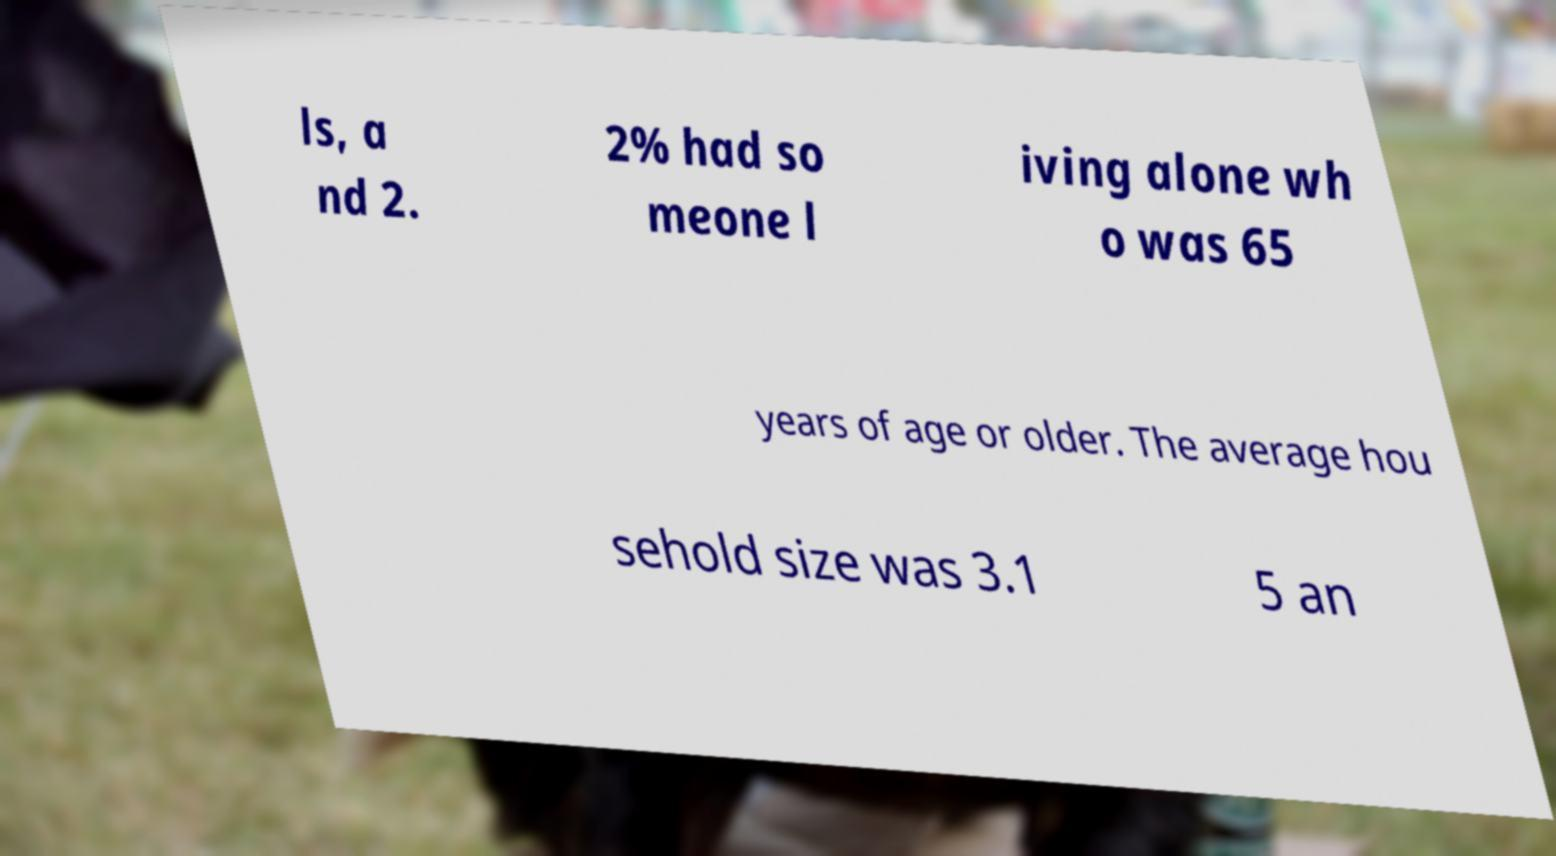I need the written content from this picture converted into text. Can you do that? ls, a nd 2. 2% had so meone l iving alone wh o was 65 years of age or older. The average hou sehold size was 3.1 5 an 